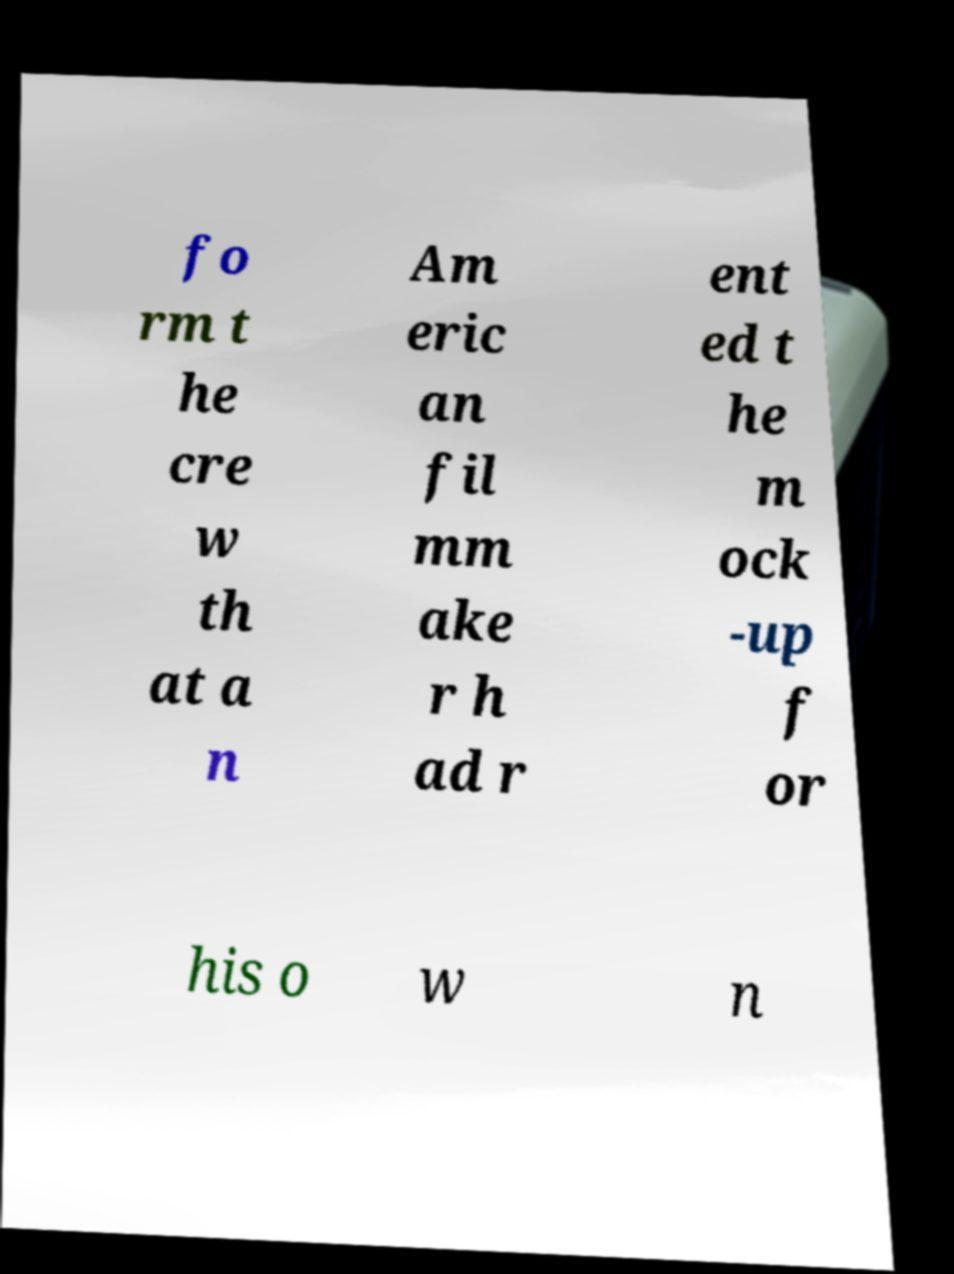Could you extract and type out the text from this image? fo rm t he cre w th at a n Am eric an fil mm ake r h ad r ent ed t he m ock -up f or his o w n 